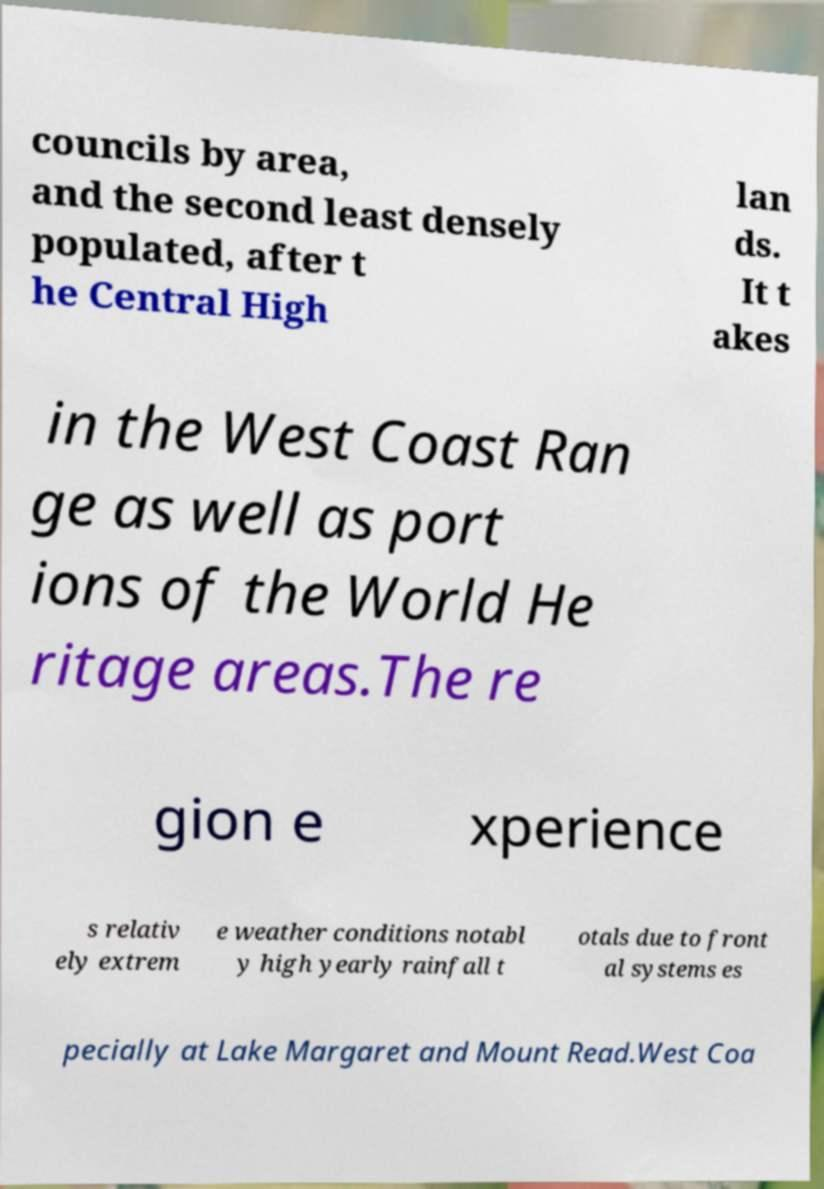Please read and relay the text visible in this image. What does it say? councils by area, and the second least densely populated, after t he Central High lan ds. It t akes in the West Coast Ran ge as well as port ions of the World He ritage areas.The re gion e xperience s relativ ely extrem e weather conditions notabl y high yearly rainfall t otals due to front al systems es pecially at Lake Margaret and Mount Read.West Coa 